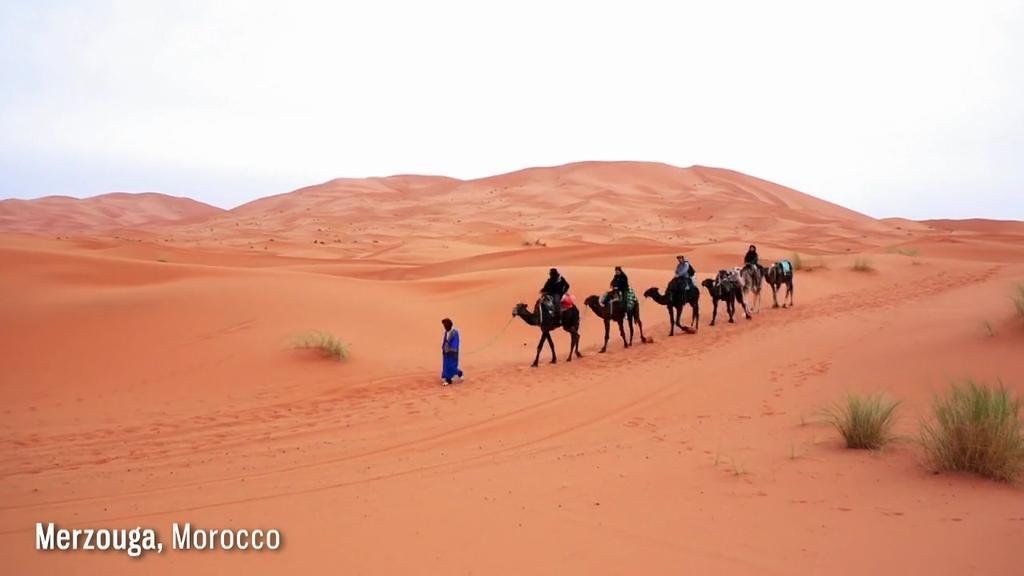In one or two sentences, can you explain what this image depicts? In the picture we can see a photograph in that we can see a desert area and some camels are walking, carrying some people and just beside we can see a person also walking and we can also see some plants and in the background we can see a sky. 